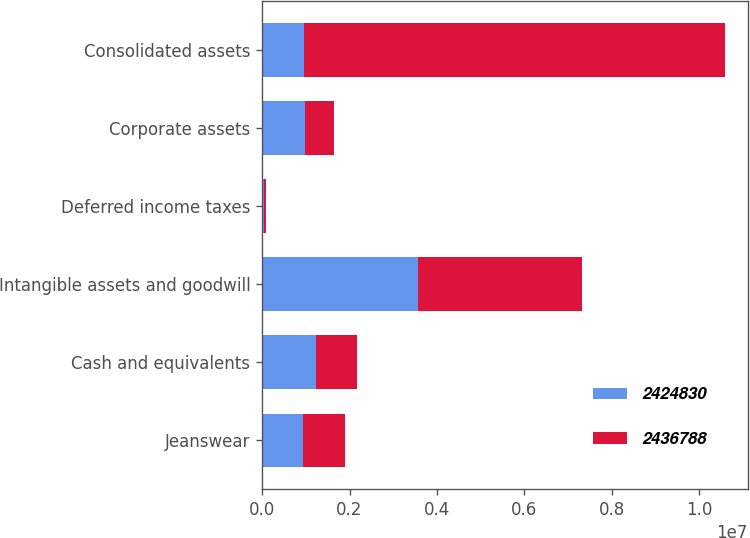Convert chart to OTSL. <chart><loc_0><loc_0><loc_500><loc_500><stacked_bar_chart><ecel><fcel>Jeanswear<fcel>Cash and equivalents<fcel>Intangible assets and goodwill<fcel>Deferred income taxes<fcel>Corporate assets<fcel>Consolidated assets<nl><fcel>2.42483e+06<fcel>943764<fcel>1.22786e+06<fcel>3.57666e+06<fcel>42231<fcel>974652<fcel>951411<nl><fcel>2.43679e+06<fcel>951411<fcel>944423<fcel>3.73702e+06<fcel>39246<fcel>661767<fcel>9.63954e+06<nl></chart> 